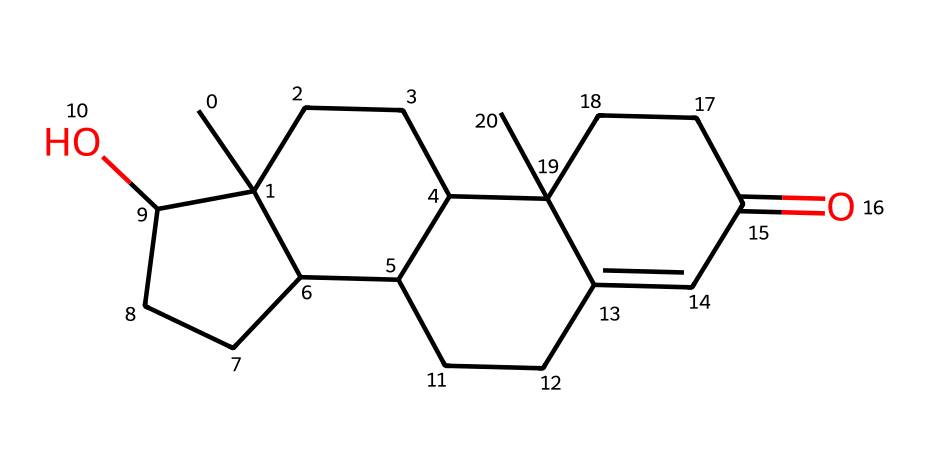What is the molecular formula of testosterone? To determine the molecular formula, we can analyze the SMILES representation, counting the number of carbon (C), hydrogen (H), and oxygen (O) atoms. The SMILES shows 19 carbons, 28 hydrogens, and 2 oxygens, leading to the formula C19H28O2.
Answer: C19H28O2 How many rings are present in the structure of testosterone? By analyzing the SMILES, we can look for numbers that indicate ring closures (e.g., 1, 2, 3). In this case, there are four distinct numerical markers that demonstrate four interconnected rings, thus confirming a tetracyclic structure.
Answer: 4 What type of compound is testosterone classified as? Testosterone is primarily categorized based on its structure and function. Given its steroidal backbone (characterized by multiple rings of carbon), it is classified as a steroid hormone.
Answer: steroid hormone What functional groups are present in testosterone? The given SMILES includes a hydroxyl group (–OH) and a ketone group (C=O) indicated in the structure. Recognizing these features, we can ascertain that testosterone has a hydroxyl group at one position and a ketone group in the structure.
Answer: hydroxyl and ketone What is the significance of the hydroxyl group in testosterone? The presence of a hydroxyl group in testosterone is crucial for its biological activity, affecting properties such as solubility in water and interaction with biological receptors. This functional group contributes to its function as a hormone in the body.
Answer: biological activity Which part of the molecule is responsible for its male sex hormone function? The core steroid structure, along with specific functional groups such as the hydroxyl group, plays a crucial role in the hormone's recognition by androgen receptors, making it essential for its actions as a male sex hormone.
Answer: steroid structure 